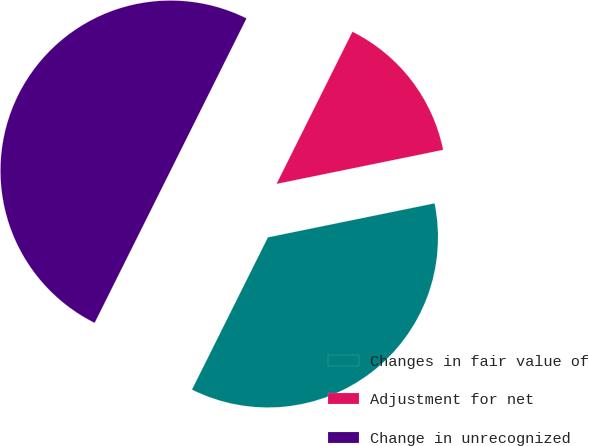<chart> <loc_0><loc_0><loc_500><loc_500><pie_chart><fcel>Changes in fair value of<fcel>Adjustment for net<fcel>Change in unrecognized<nl><fcel>35.57%<fcel>14.43%<fcel>50.0%<nl></chart> 